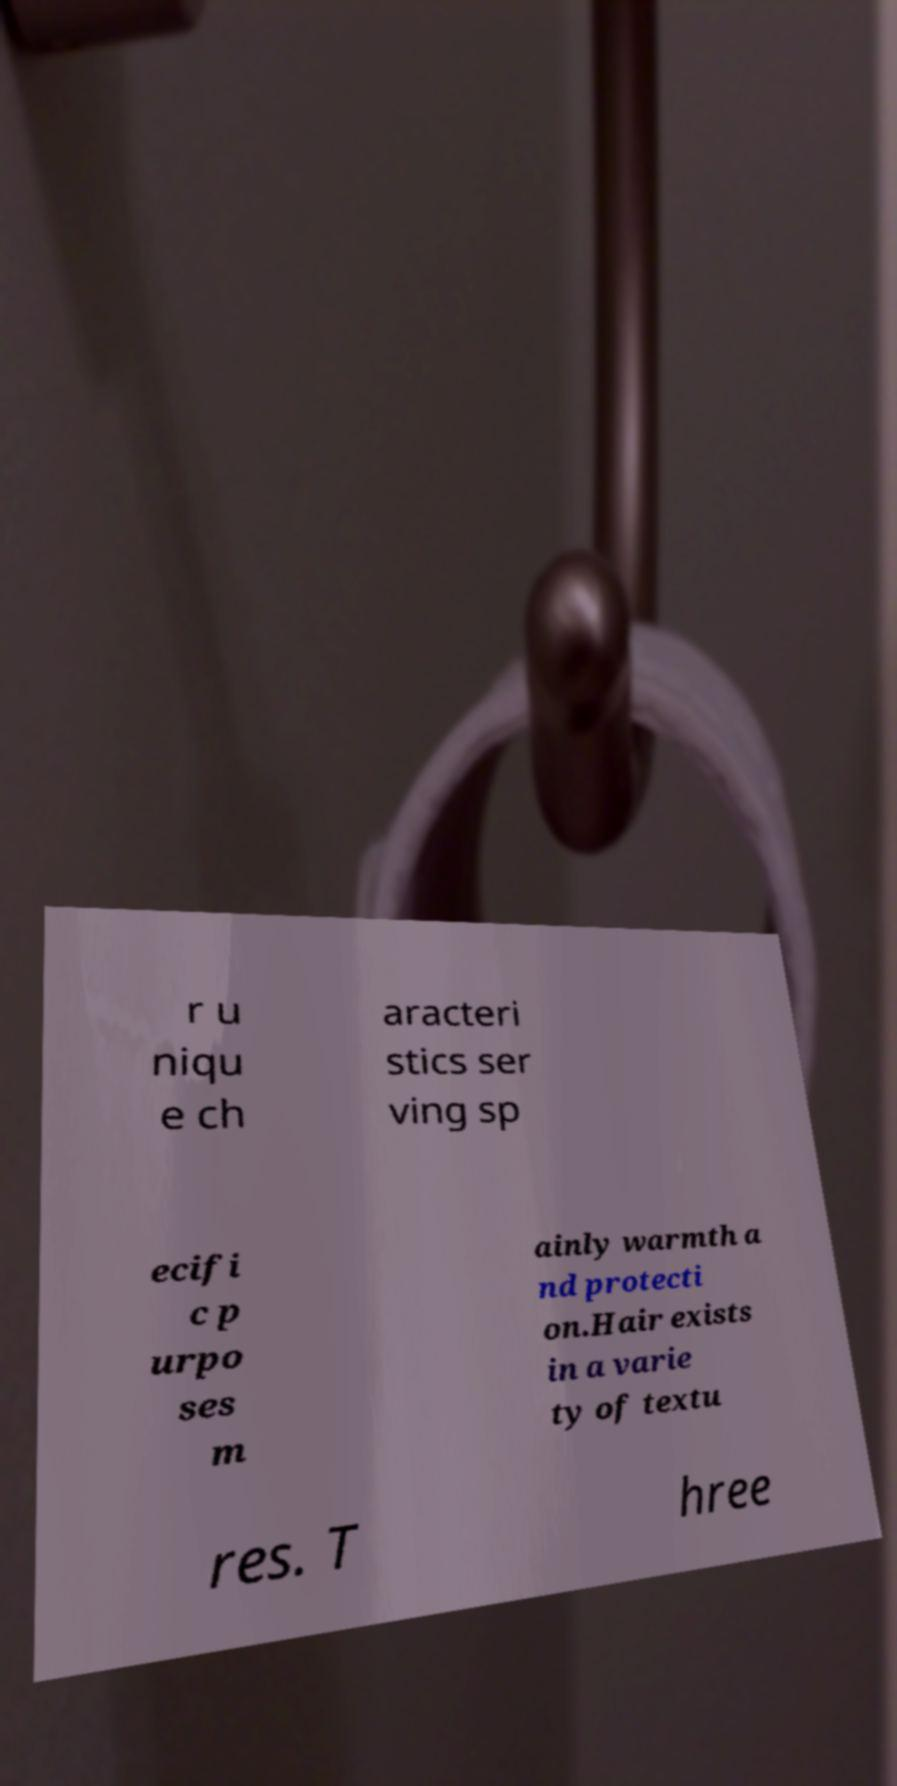Please read and relay the text visible in this image. What does it say? r u niqu e ch aracteri stics ser ving sp ecifi c p urpo ses m ainly warmth a nd protecti on.Hair exists in a varie ty of textu res. T hree 